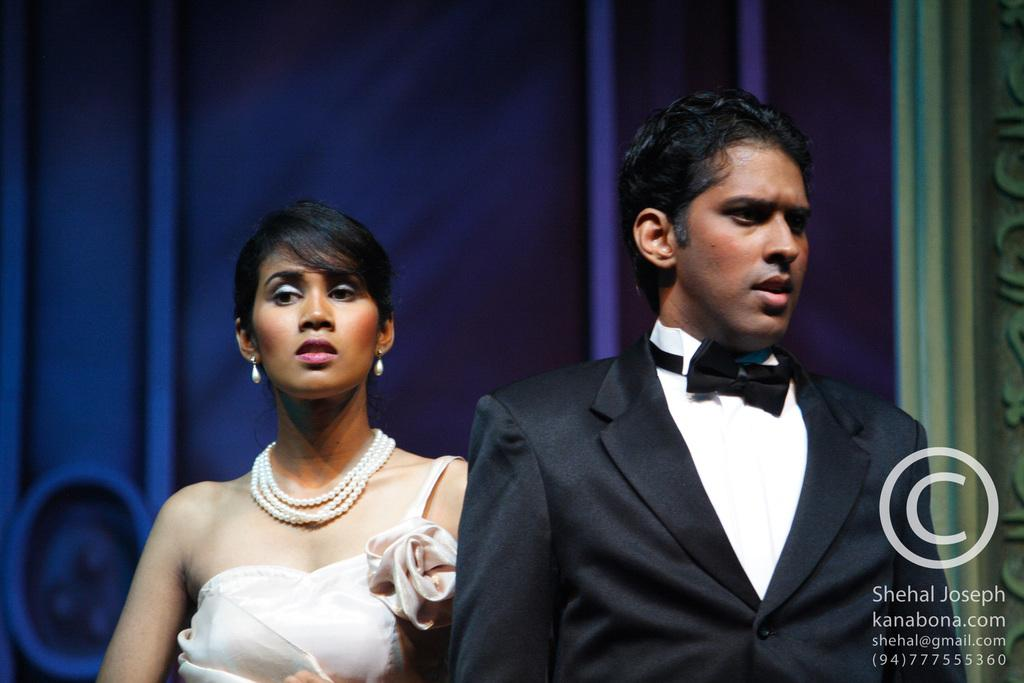Who are the subjects in the image? There is a boy and a girl in the image. Where are the boy and girl located in the image? The boy and girl are in the center of the image. What type of club does the girl recommend to the boy in the image? There is no club or recommendation present in the image; it simply features a boy and a girl in the center. 